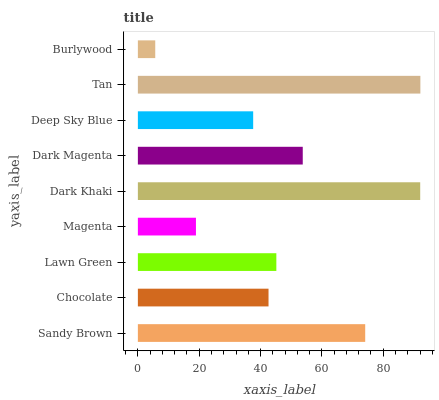Is Burlywood the minimum?
Answer yes or no. Yes. Is Tan the maximum?
Answer yes or no. Yes. Is Chocolate the minimum?
Answer yes or no. No. Is Chocolate the maximum?
Answer yes or no. No. Is Sandy Brown greater than Chocolate?
Answer yes or no. Yes. Is Chocolate less than Sandy Brown?
Answer yes or no. Yes. Is Chocolate greater than Sandy Brown?
Answer yes or no. No. Is Sandy Brown less than Chocolate?
Answer yes or no. No. Is Lawn Green the high median?
Answer yes or no. Yes. Is Lawn Green the low median?
Answer yes or no. Yes. Is Dark Magenta the high median?
Answer yes or no. No. Is Deep Sky Blue the low median?
Answer yes or no. No. 